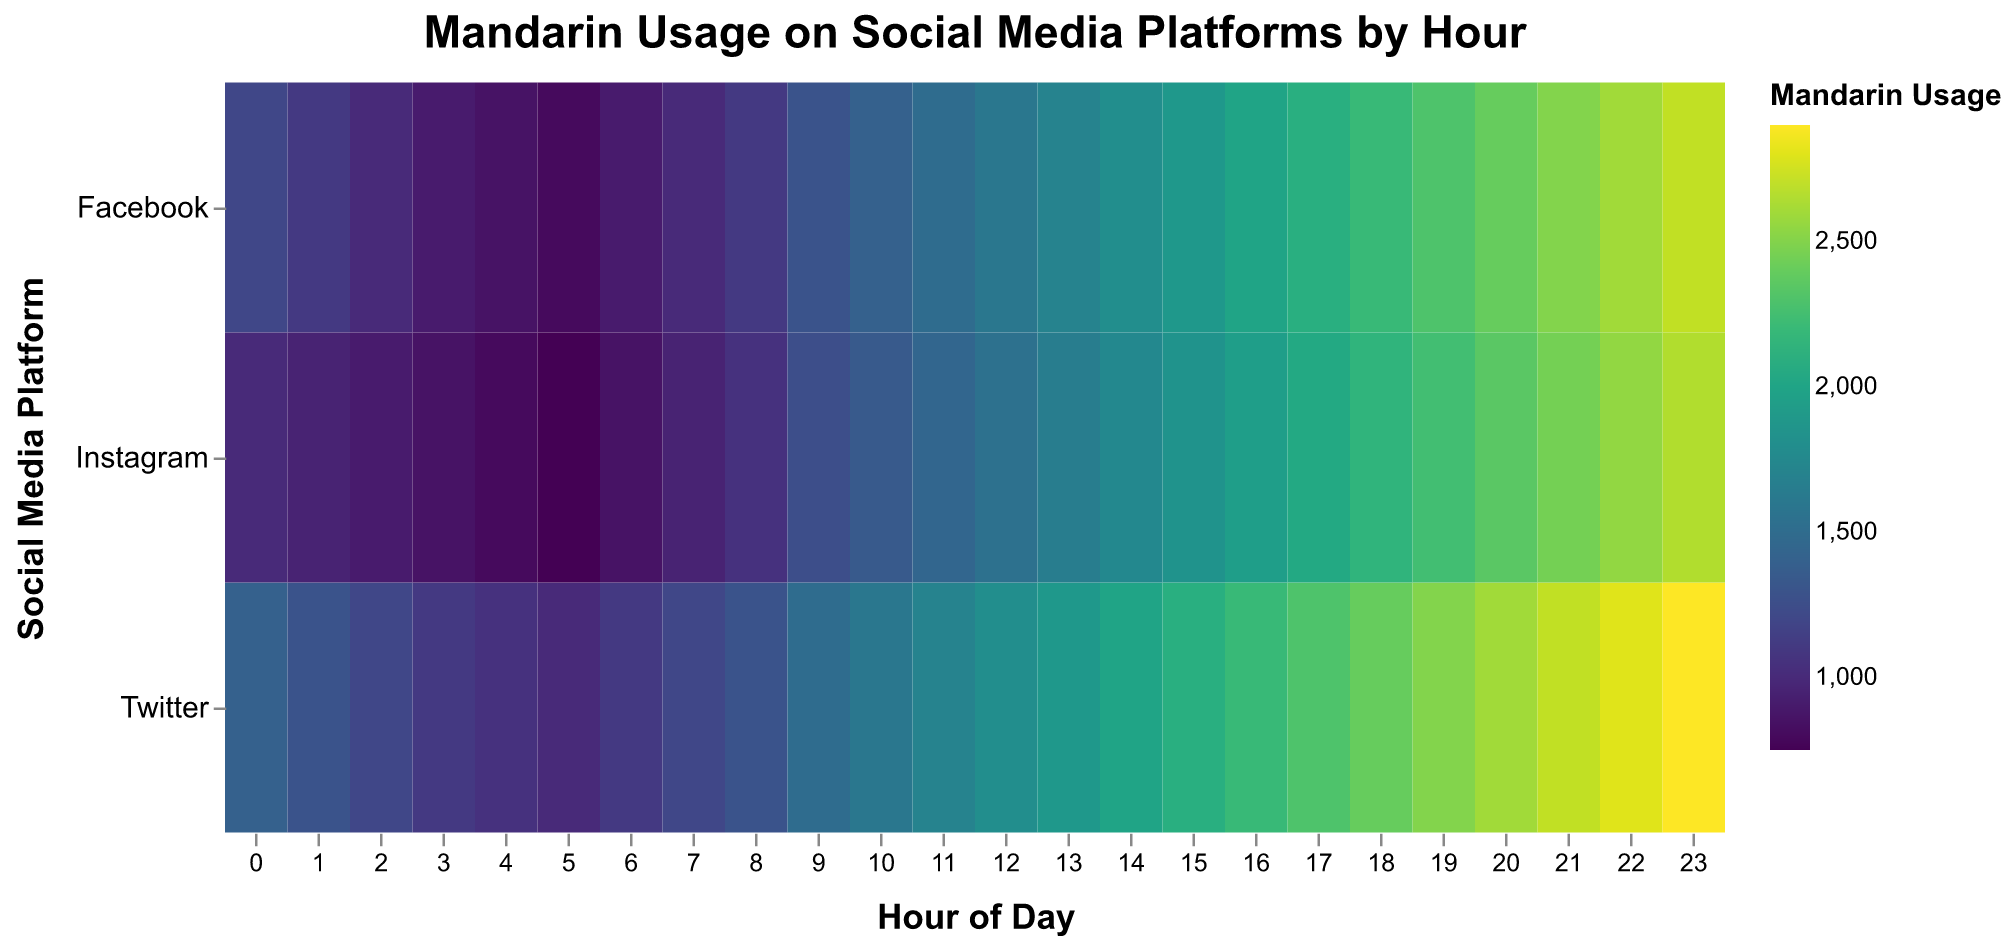What is the title of the heatmap? The title is displayed at the top center of the heatmap. It is "Mandarin Usage on Social Media Platforms by Hour" as specified in the title property of the chart.
Answer: Mandarin Usage on Social Media Platforms by Hour Which social media platform shows the highest Mandarin usage at 9 AM? By looking at the grid cell at the intersection of "Facebook" and the "9" hour, Facebook shows the highest Mandarin usage for this hour, as the color intensity suggests higher usage compared to Twitter and Instagram.
Answer: Facebook What is the average Mandarin usage on Facebook at 10 AM and 11 AM? From the figure, Mandarin usage at 10 AM on Facebook is 1400 and at 11 AM is 1500. The average is calculated as (1400 + 1500) / 2 = 1450.
Answer: 1450 Between Twitter and Instagram, which platform has higher Mandarin usage at 3 PM? At 3 PM (15), Twitter has Mandarin usage of 2100, while Instagram has 1850. Comparing these values, Twitter has higher Mandarin usage.
Answer: Twitter At what hour does Instagram show the peak Japanese usage? By observing the different color intensities along Instagram's row, the highest intensity (deepest color) corresponds to 11 PM (23), which suggests peak usage.
Answer: 11 PM What is the total Mandarin usage on Facebook from 8 AM to 10 AM? Mandarin usages at 8 AM, 9 AM, and 10 AM on Facebook are 1100, 1300, and 1400, respectively. Summing these values: 1100 + 1300 + 1400 = 3800.
Answer: 3800 Which social media platform shows the highest increase in Mandarin usage from 5 AM to 6 AM, and what is the difference? Comparing the Mandarin usage at 5 AM and 6 AM for each platform: 
   - Facebook: 800 to 900 (increase of 100)
   - Twitter: 1000 to 1100 (increase of 100)
   - Instagram: 750 to 850 (increase of 100)
   All platforms show the same increase of 100.
Answer: Facebook, Twitter, Instagram (each increased by 100) What time of day does Twitter consistently show higher Japanese usage than Instagram? Observing Twitter and Instagram rows side by side, from midnight (0) to 11 PM (23), consistently higher values are on Twitter over the entire day indicating consistent higher Japanese usage.
Answer: Whole day Based on the colors' intensity, which hour has the least Mandarin usage for all platforms? Inspecting for the lightest color across rows, it appears to be at early hours like 4 AM, which has lower Mandarin usage values compared to others.
Answer: 4 AM How does Mandarin usage on Facebook at 11 PM compare to the usage at 11 AM? Checking 11 PM and 11 AM on Facebook row, the Mandarin usage is 2700 at 11 PM and 1500 at 11 AM. Therefore, 11 PM usage is higher.
Answer: 11 PM (2700) > 11 AM (1500) 